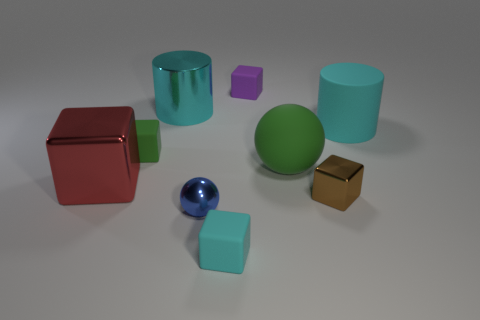What number of other objects are there of the same color as the metallic cylinder?
Provide a short and direct response. 2. There is a large thing that is the same shape as the tiny brown object; what is its color?
Your answer should be compact. Red. Is there any other thing that has the same shape as the big red thing?
Keep it short and to the point. Yes. What shape is the cyan rubber object that is behind the small green cube?
Offer a terse response. Cylinder. What number of matte things are the same shape as the red metallic thing?
Give a very brief answer. 3. There is a large metal thing behind the large green rubber sphere; is its color the same as the ball that is in front of the brown shiny block?
Your answer should be very brief. No. What number of things are purple blocks or blue things?
Offer a very short reply. 2. What number of blue cylinders have the same material as the tiny purple block?
Your answer should be very brief. 0. Are there fewer brown shiny cylinders than small cyan objects?
Your answer should be very brief. Yes. Are the large cyan cylinder on the right side of the small brown thing and the small green thing made of the same material?
Keep it short and to the point. Yes. 